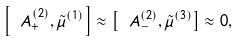<formula> <loc_0><loc_0><loc_500><loc_500>\left [ \ A ^ { ( 2 ) } _ { + } , \tilde { \mu } ^ { ( 1 ) } \right ] \approx \left [ \ A ^ { ( 2 ) } _ { - } , \tilde { \mu } ^ { ( 3 ) } \right ] \approx 0 ,</formula> 